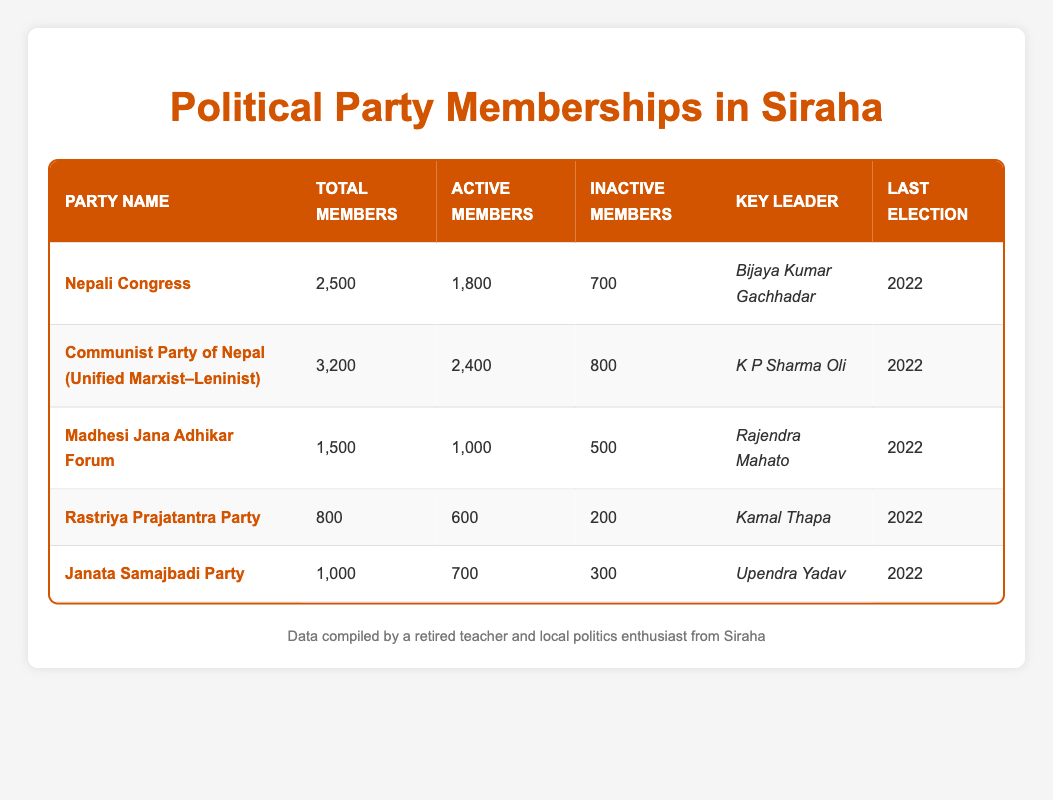What is the total membership count for the Communist Party of Nepal (Unified Marxist–Leninist)? The total membership count for this party can be found in the "Total Members" column corresponding to that party's row, which indicates 3,200 members.
Answer: 3200 How many active members does the Nepali Congress have? The "Active Members" column for Nepali Congress shows that there are 1,800 active members.
Answer: 1800 Which party has the highest number of inactive members? To find the party with the highest number of inactive members, we compare the "Inactive Members" column across all parties. The Communist Party of Nepal (Unified Marxist–Leninist) shows the highest number with 800 inactive members.
Answer: Communist Party of Nepal (Unified Marxist–Leninist) Is it true that the Janata Samajbadi Party has more active members than the Rastriya Prajatantra Party? By comparing the "Active Members" for both parties, Janata Samajbadi Party has 700 while Rastriya Prajatantra Party has 600, confirming that Janata Samajbadi Party has more active members.
Answer: Yes What is the total number of active members across all parties listed? To find the total number of active members, we sum the values in the "Active Members" column: 1,800 (Nepali Congress) + 2,400 (Communist Party of Nepal) + 1,000 (Madhesi Jana Adhikar Forum) + 600 (Rastriya Prajatantra Party) + 700 (Janata Samajbadi Party) = 6,500 active members.
Answer: 6500 Which party has the lowest total membership count? We look at the "Total Members" column and notice that the Rastriya Prajatantra Party has the lowest total membership count of 800 members.
Answer: Rastriya Prajatantra Party How many total members are there among the parties with active membership greater than 1,000? Focusing on parties with active members greater than 1,000: Nepali Congress (2,500), Communist Party of Nepal (3,200), and Madhesi Jana Adhikar Forum (1,500); adding them gives 2,500 + 3,200 + 1,500 = 7,200 total members.
Answer: 7200 Is the key leader for Madhesi Jana Adhikar Forum different from that of Janata Samajbadi Party? By examining the "Key Leader" column, we see that Madhesi Jana Adhikar Forum has Rajendra Mahato while Janata Samajbadi Party has Upendra Yadav, confirming the leaders are different.
Answer: Yes 